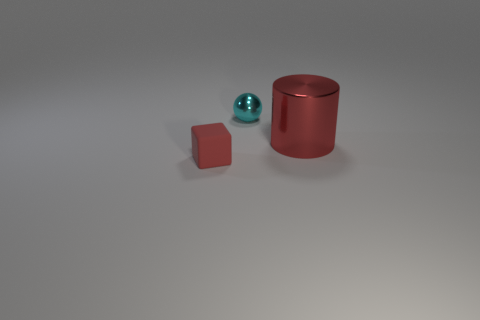Are there any other things that are the same size as the red shiny cylinder?
Keep it short and to the point. No. How many other things are there of the same material as the tiny cube?
Make the answer very short. 0. What material is the ball?
Provide a short and direct response. Metal. How many tiny objects are brown blocks or red cylinders?
Make the answer very short. 0. How many red metallic cylinders are on the right side of the big red metallic thing?
Make the answer very short. 0. Is there a rubber object that has the same color as the small shiny sphere?
Ensure brevity in your answer.  No. The red thing that is the same size as the cyan object is what shape?
Give a very brief answer. Cube. How many purple things are either small balls or large metallic things?
Your response must be concise. 0. What number of balls are the same size as the cyan metal object?
Your answer should be very brief. 0. What shape is the large object that is the same color as the tiny rubber block?
Your answer should be compact. Cylinder. 